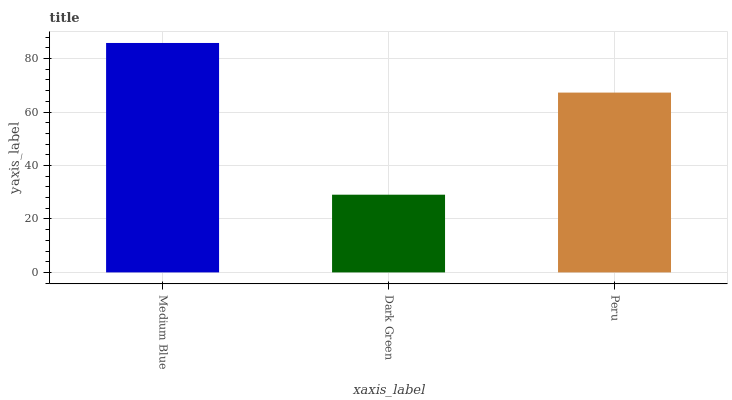Is Dark Green the minimum?
Answer yes or no. Yes. Is Medium Blue the maximum?
Answer yes or no. Yes. Is Peru the minimum?
Answer yes or no. No. Is Peru the maximum?
Answer yes or no. No. Is Peru greater than Dark Green?
Answer yes or no. Yes. Is Dark Green less than Peru?
Answer yes or no. Yes. Is Dark Green greater than Peru?
Answer yes or no. No. Is Peru less than Dark Green?
Answer yes or no. No. Is Peru the high median?
Answer yes or no. Yes. Is Peru the low median?
Answer yes or no. Yes. Is Medium Blue the high median?
Answer yes or no. No. Is Medium Blue the low median?
Answer yes or no. No. 